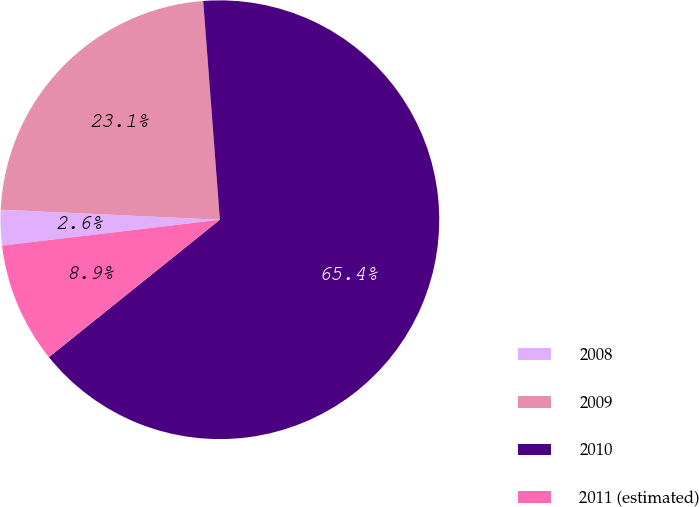Convert chart to OTSL. <chart><loc_0><loc_0><loc_500><loc_500><pie_chart><fcel>2008<fcel>2009<fcel>2010<fcel>2011 (estimated)<nl><fcel>2.61%<fcel>23.06%<fcel>65.43%<fcel>8.89%<nl></chart> 